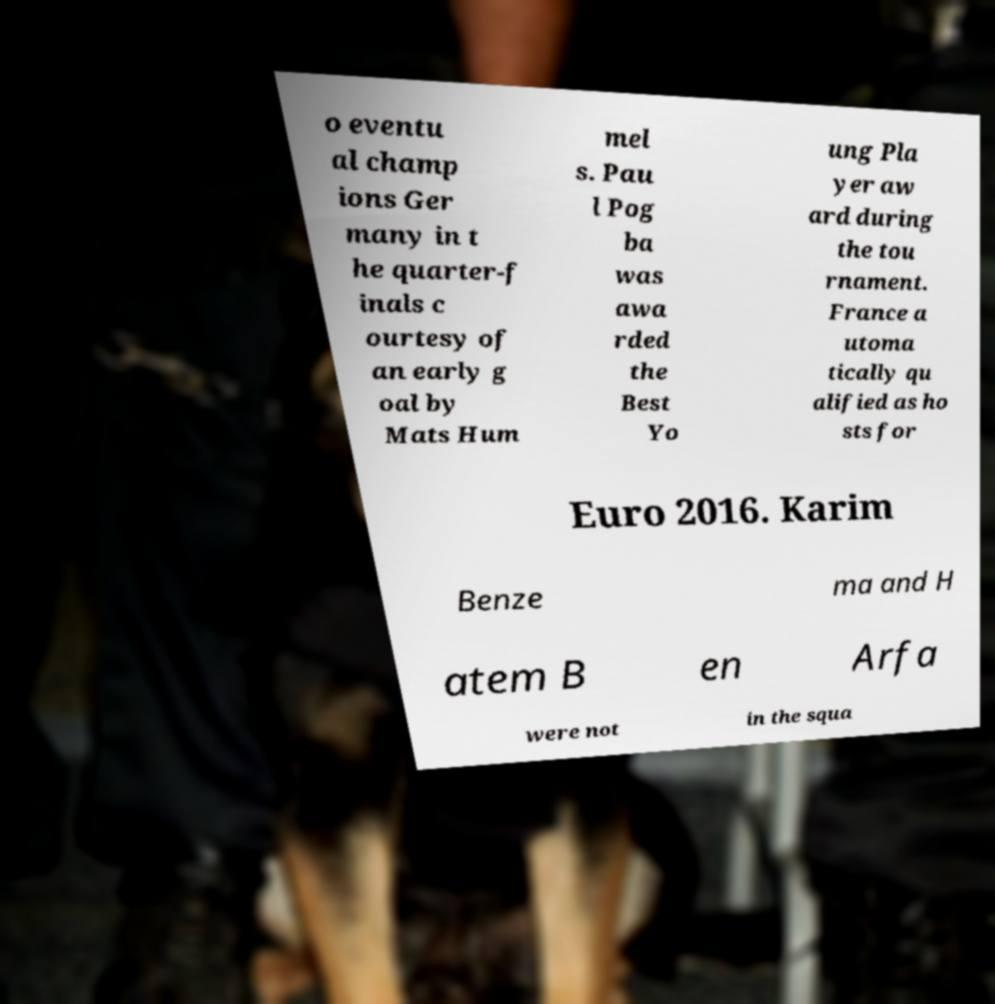For documentation purposes, I need the text within this image transcribed. Could you provide that? o eventu al champ ions Ger many in t he quarter-f inals c ourtesy of an early g oal by Mats Hum mel s. Pau l Pog ba was awa rded the Best Yo ung Pla yer aw ard during the tou rnament. France a utoma tically qu alified as ho sts for Euro 2016. Karim Benze ma and H atem B en Arfa were not in the squa 